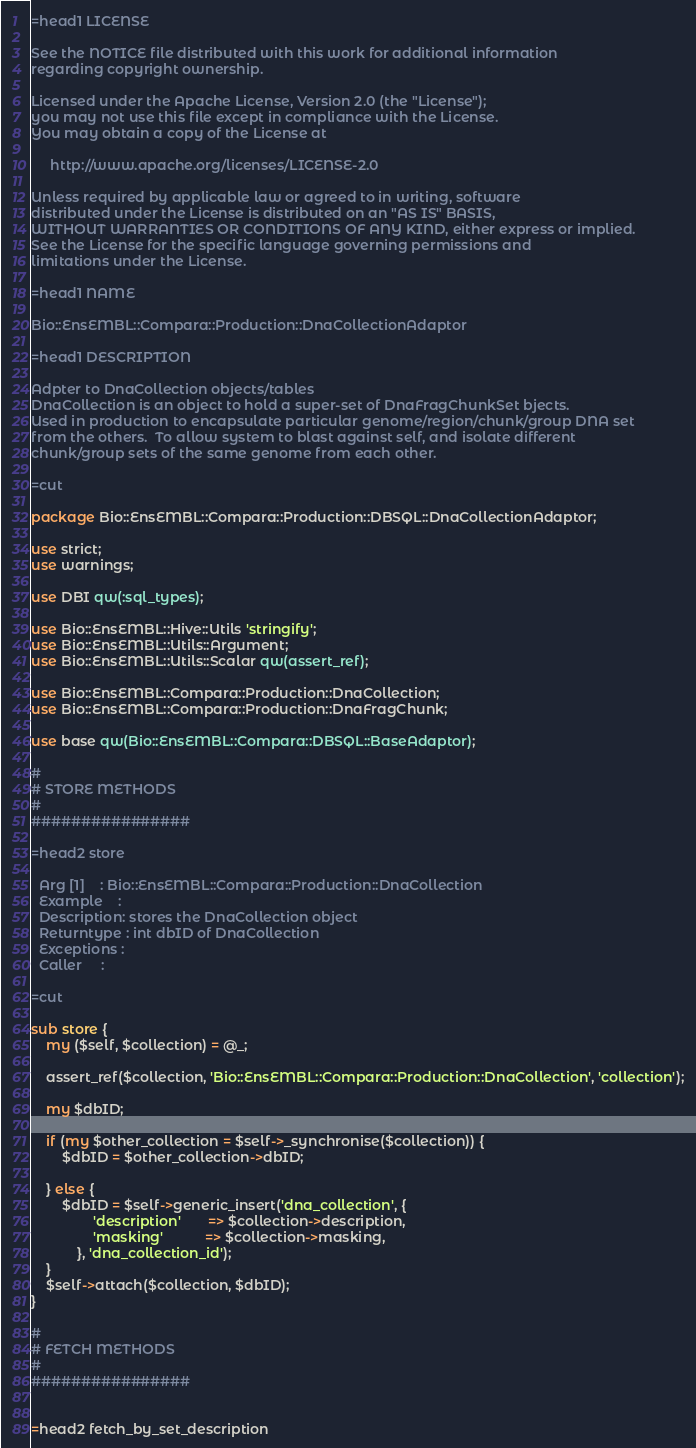Convert code to text. <code><loc_0><loc_0><loc_500><loc_500><_Perl_>=head1 LICENSE

See the NOTICE file distributed with this work for additional information
regarding copyright ownership.

Licensed under the Apache License, Version 2.0 (the "License");
you may not use this file except in compliance with the License.
You may obtain a copy of the License at

     http://www.apache.org/licenses/LICENSE-2.0

Unless required by applicable law or agreed to in writing, software
distributed under the License is distributed on an "AS IS" BASIS,
WITHOUT WARRANTIES OR CONDITIONS OF ANY KIND, either express or implied.
See the License for the specific language governing permissions and
limitations under the License.

=head1 NAME

Bio::EnsEMBL::Compara::Production::DnaCollectionAdaptor

=head1 DESCRIPTION

Adpter to DnaCollection objects/tables
DnaCollection is an object to hold a super-set of DnaFragChunkSet bjects.  
Used in production to encapsulate particular genome/region/chunk/group DNA set
from the others.  To allow system to blast against self, and isolate different 
chunk/group sets of the same genome from each other.

=cut

package Bio::EnsEMBL::Compara::Production::DBSQL::DnaCollectionAdaptor;

use strict;
use warnings;

use DBI qw(:sql_types);

use Bio::EnsEMBL::Hive::Utils 'stringify';
use Bio::EnsEMBL::Utils::Argument;
use Bio::EnsEMBL::Utils::Scalar qw(assert_ref);

use Bio::EnsEMBL::Compara::Production::DnaCollection;
use Bio::EnsEMBL::Compara::Production::DnaFragChunk;

use base qw(Bio::EnsEMBL::Compara::DBSQL::BaseAdaptor);

#
# STORE METHODS
#
################

=head2 store

  Arg [1]    : Bio::EnsEMBL::Compara::Production::DnaCollection
  Example    :
  Description: stores the DnaCollection object
  Returntype : int dbID of DnaCollection
  Exceptions :
  Caller     :

=cut

sub store {
    my ($self, $collection) = @_;
    
    assert_ref($collection, 'Bio::EnsEMBL::Compara::Production::DnaCollection', 'collection');

    my $dbID;

    if (my $other_collection = $self->_synchronise($collection)) {
        $dbID = $other_collection->dbID;

    } else {
        $dbID = $self->generic_insert('dna_collection', {
                'description'       => $collection->description,
                'masking'           => $collection->masking,
            }, 'dna_collection_id');
    }
    $self->attach($collection, $dbID);
}

#
# FETCH METHODS
#
################


=head2 fetch_by_set_description
</code> 